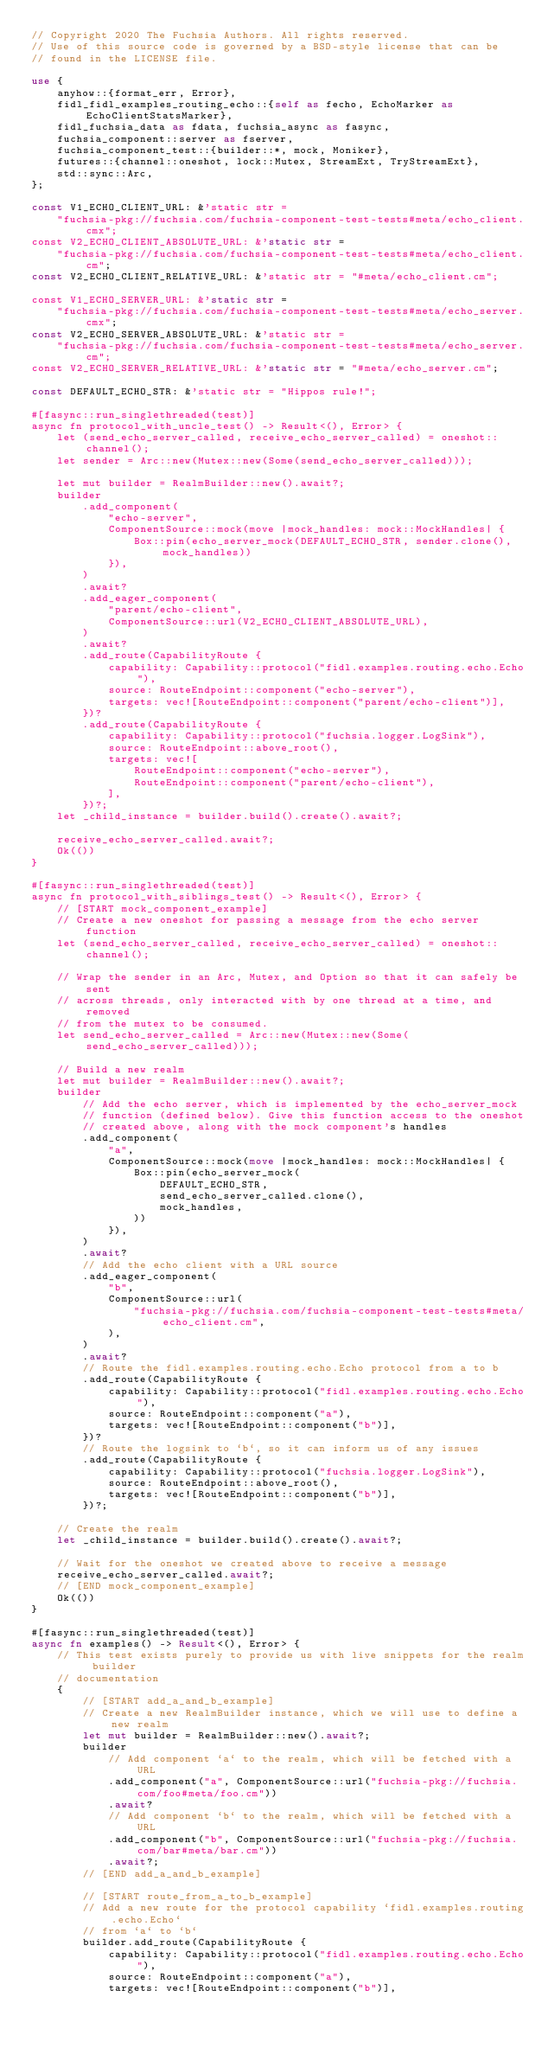Convert code to text. <code><loc_0><loc_0><loc_500><loc_500><_Rust_>// Copyright 2020 The Fuchsia Authors. All rights reserved.
// Use of this source code is governed by a BSD-style license that can be
// found in the LICENSE file.

use {
    anyhow::{format_err, Error},
    fidl_fidl_examples_routing_echo::{self as fecho, EchoMarker as EchoClientStatsMarker},
    fidl_fuchsia_data as fdata, fuchsia_async as fasync,
    fuchsia_component::server as fserver,
    fuchsia_component_test::{builder::*, mock, Moniker},
    futures::{channel::oneshot, lock::Mutex, StreamExt, TryStreamExt},
    std::sync::Arc,
};

const V1_ECHO_CLIENT_URL: &'static str =
    "fuchsia-pkg://fuchsia.com/fuchsia-component-test-tests#meta/echo_client.cmx";
const V2_ECHO_CLIENT_ABSOLUTE_URL: &'static str =
    "fuchsia-pkg://fuchsia.com/fuchsia-component-test-tests#meta/echo_client.cm";
const V2_ECHO_CLIENT_RELATIVE_URL: &'static str = "#meta/echo_client.cm";

const V1_ECHO_SERVER_URL: &'static str =
    "fuchsia-pkg://fuchsia.com/fuchsia-component-test-tests#meta/echo_server.cmx";
const V2_ECHO_SERVER_ABSOLUTE_URL: &'static str =
    "fuchsia-pkg://fuchsia.com/fuchsia-component-test-tests#meta/echo_server.cm";
const V2_ECHO_SERVER_RELATIVE_URL: &'static str = "#meta/echo_server.cm";

const DEFAULT_ECHO_STR: &'static str = "Hippos rule!";

#[fasync::run_singlethreaded(test)]
async fn protocol_with_uncle_test() -> Result<(), Error> {
    let (send_echo_server_called, receive_echo_server_called) = oneshot::channel();
    let sender = Arc::new(Mutex::new(Some(send_echo_server_called)));

    let mut builder = RealmBuilder::new().await?;
    builder
        .add_component(
            "echo-server",
            ComponentSource::mock(move |mock_handles: mock::MockHandles| {
                Box::pin(echo_server_mock(DEFAULT_ECHO_STR, sender.clone(), mock_handles))
            }),
        )
        .await?
        .add_eager_component(
            "parent/echo-client",
            ComponentSource::url(V2_ECHO_CLIENT_ABSOLUTE_URL),
        )
        .await?
        .add_route(CapabilityRoute {
            capability: Capability::protocol("fidl.examples.routing.echo.Echo"),
            source: RouteEndpoint::component("echo-server"),
            targets: vec![RouteEndpoint::component("parent/echo-client")],
        })?
        .add_route(CapabilityRoute {
            capability: Capability::protocol("fuchsia.logger.LogSink"),
            source: RouteEndpoint::above_root(),
            targets: vec![
                RouteEndpoint::component("echo-server"),
                RouteEndpoint::component("parent/echo-client"),
            ],
        })?;
    let _child_instance = builder.build().create().await?;

    receive_echo_server_called.await?;
    Ok(())
}

#[fasync::run_singlethreaded(test)]
async fn protocol_with_siblings_test() -> Result<(), Error> {
    // [START mock_component_example]
    // Create a new oneshot for passing a message from the echo server function
    let (send_echo_server_called, receive_echo_server_called) = oneshot::channel();

    // Wrap the sender in an Arc, Mutex, and Option so that it can safely be sent
    // across threads, only interacted with by one thread at a time, and removed
    // from the mutex to be consumed.
    let send_echo_server_called = Arc::new(Mutex::new(Some(send_echo_server_called)));

    // Build a new realm
    let mut builder = RealmBuilder::new().await?;
    builder
        // Add the echo server, which is implemented by the echo_server_mock
        // function (defined below). Give this function access to the oneshot
        // created above, along with the mock component's handles
        .add_component(
            "a",
            ComponentSource::mock(move |mock_handles: mock::MockHandles| {
                Box::pin(echo_server_mock(
                    DEFAULT_ECHO_STR,
                    send_echo_server_called.clone(),
                    mock_handles,
                ))
            }),
        )
        .await?
        // Add the echo client with a URL source
        .add_eager_component(
            "b",
            ComponentSource::url(
                "fuchsia-pkg://fuchsia.com/fuchsia-component-test-tests#meta/echo_client.cm",
            ),
        )
        .await?
        // Route the fidl.examples.routing.echo.Echo protocol from a to b
        .add_route(CapabilityRoute {
            capability: Capability::protocol("fidl.examples.routing.echo.Echo"),
            source: RouteEndpoint::component("a"),
            targets: vec![RouteEndpoint::component("b")],
        })?
        // Route the logsink to `b`, so it can inform us of any issues
        .add_route(CapabilityRoute {
            capability: Capability::protocol("fuchsia.logger.LogSink"),
            source: RouteEndpoint::above_root(),
            targets: vec![RouteEndpoint::component("b")],
        })?;

    // Create the realm
    let _child_instance = builder.build().create().await?;

    // Wait for the oneshot we created above to receive a message
    receive_echo_server_called.await?;
    // [END mock_component_example]
    Ok(())
}

#[fasync::run_singlethreaded(test)]
async fn examples() -> Result<(), Error> {
    // This test exists purely to provide us with live snippets for the realm builder
    // documentation
    {
        // [START add_a_and_b_example]
        // Create a new RealmBuilder instance, which we will use to define a new realm
        let mut builder = RealmBuilder::new().await?;
        builder
            // Add component `a` to the realm, which will be fetched with a URL
            .add_component("a", ComponentSource::url("fuchsia-pkg://fuchsia.com/foo#meta/foo.cm"))
            .await?
            // Add component `b` to the realm, which will be fetched with a URL
            .add_component("b", ComponentSource::url("fuchsia-pkg://fuchsia.com/bar#meta/bar.cm"))
            .await?;
        // [END add_a_and_b_example]

        // [START route_from_a_to_b_example]
        // Add a new route for the protocol capability `fidl.examples.routing.echo.Echo`
        // from `a` to `b`
        builder.add_route(CapabilityRoute {
            capability: Capability::protocol("fidl.examples.routing.echo.Echo"),
            source: RouteEndpoint::component("a"),
            targets: vec![RouteEndpoint::component("b")],</code> 